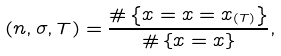<formula> <loc_0><loc_0><loc_500><loc_500>( n , \sigma , T ) = \frac { \# \left \{ x = x = x _ { ( T ) } \right \} } { \# \left \{ x = x \right \} } ,</formula> 